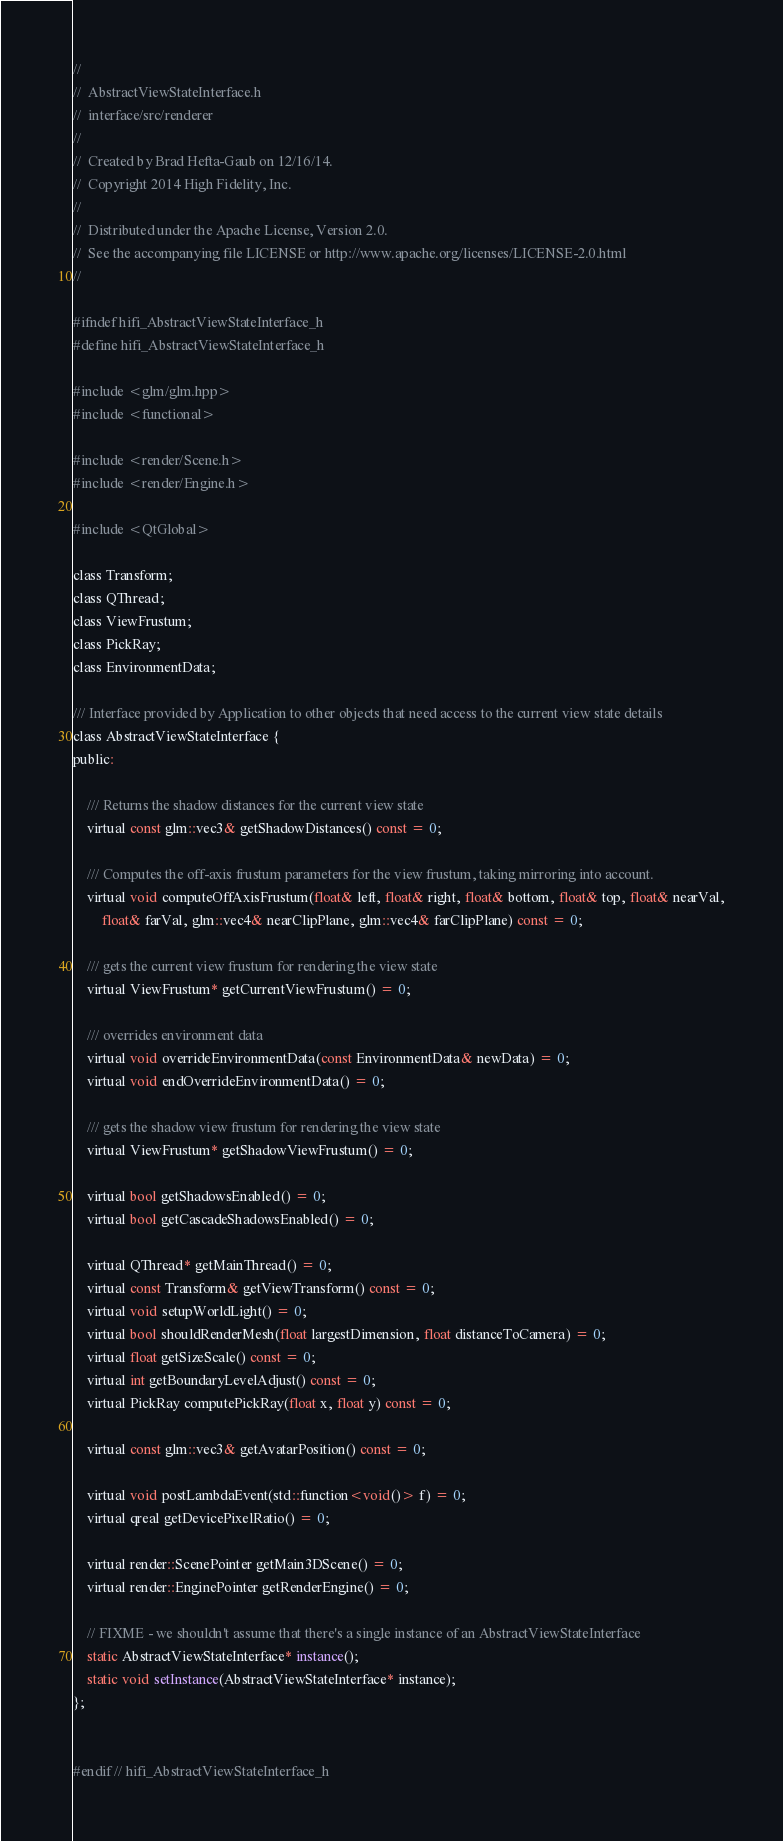<code> <loc_0><loc_0><loc_500><loc_500><_C_>//
//  AbstractViewStateInterface.h
//  interface/src/renderer
//
//  Created by Brad Hefta-Gaub on 12/16/14.
//  Copyright 2014 High Fidelity, Inc.
//
//  Distributed under the Apache License, Version 2.0.
//  See the accompanying file LICENSE or http://www.apache.org/licenses/LICENSE-2.0.html
//

#ifndef hifi_AbstractViewStateInterface_h
#define hifi_AbstractViewStateInterface_h

#include <glm/glm.hpp>
#include <functional>

#include <render/Scene.h>
#include <render/Engine.h>

#include <QtGlobal>

class Transform;
class QThread;
class ViewFrustum;
class PickRay;
class EnvironmentData;

/// Interface provided by Application to other objects that need access to the current view state details
class AbstractViewStateInterface {
public:
    
    /// Returns the shadow distances for the current view state
    virtual const glm::vec3& getShadowDistances() const = 0;

    /// Computes the off-axis frustum parameters for the view frustum, taking mirroring into account.
    virtual void computeOffAxisFrustum(float& left, float& right, float& bottom, float& top, float& nearVal,
        float& farVal, glm::vec4& nearClipPlane, glm::vec4& farClipPlane) const = 0;

    /// gets the current view frustum for rendering the view state
    virtual ViewFrustum* getCurrentViewFrustum() = 0;

    /// overrides environment data
    virtual void overrideEnvironmentData(const EnvironmentData& newData) = 0;
    virtual void endOverrideEnvironmentData() = 0;

    /// gets the shadow view frustum for rendering the view state
    virtual ViewFrustum* getShadowViewFrustum() = 0;

    virtual bool getShadowsEnabled() = 0;
    virtual bool getCascadeShadowsEnabled() = 0;

    virtual QThread* getMainThread() = 0;
    virtual const Transform& getViewTransform() const = 0;
    virtual void setupWorldLight() = 0;
    virtual bool shouldRenderMesh(float largestDimension, float distanceToCamera) = 0;
    virtual float getSizeScale() const = 0;
    virtual int getBoundaryLevelAdjust() const = 0;
    virtual PickRay computePickRay(float x, float y) const = 0;

    virtual const glm::vec3& getAvatarPosition() const = 0;

    virtual void postLambdaEvent(std::function<void()> f) = 0;
    virtual qreal getDevicePixelRatio() = 0;

    virtual render::ScenePointer getMain3DScene() = 0;
    virtual render::EnginePointer getRenderEngine() = 0;

    // FIXME - we shouldn't assume that there's a single instance of an AbstractViewStateInterface
    static AbstractViewStateInterface* instance();
    static void setInstance(AbstractViewStateInterface* instance);
};


#endif // hifi_AbstractViewStateInterface_h
</code> 